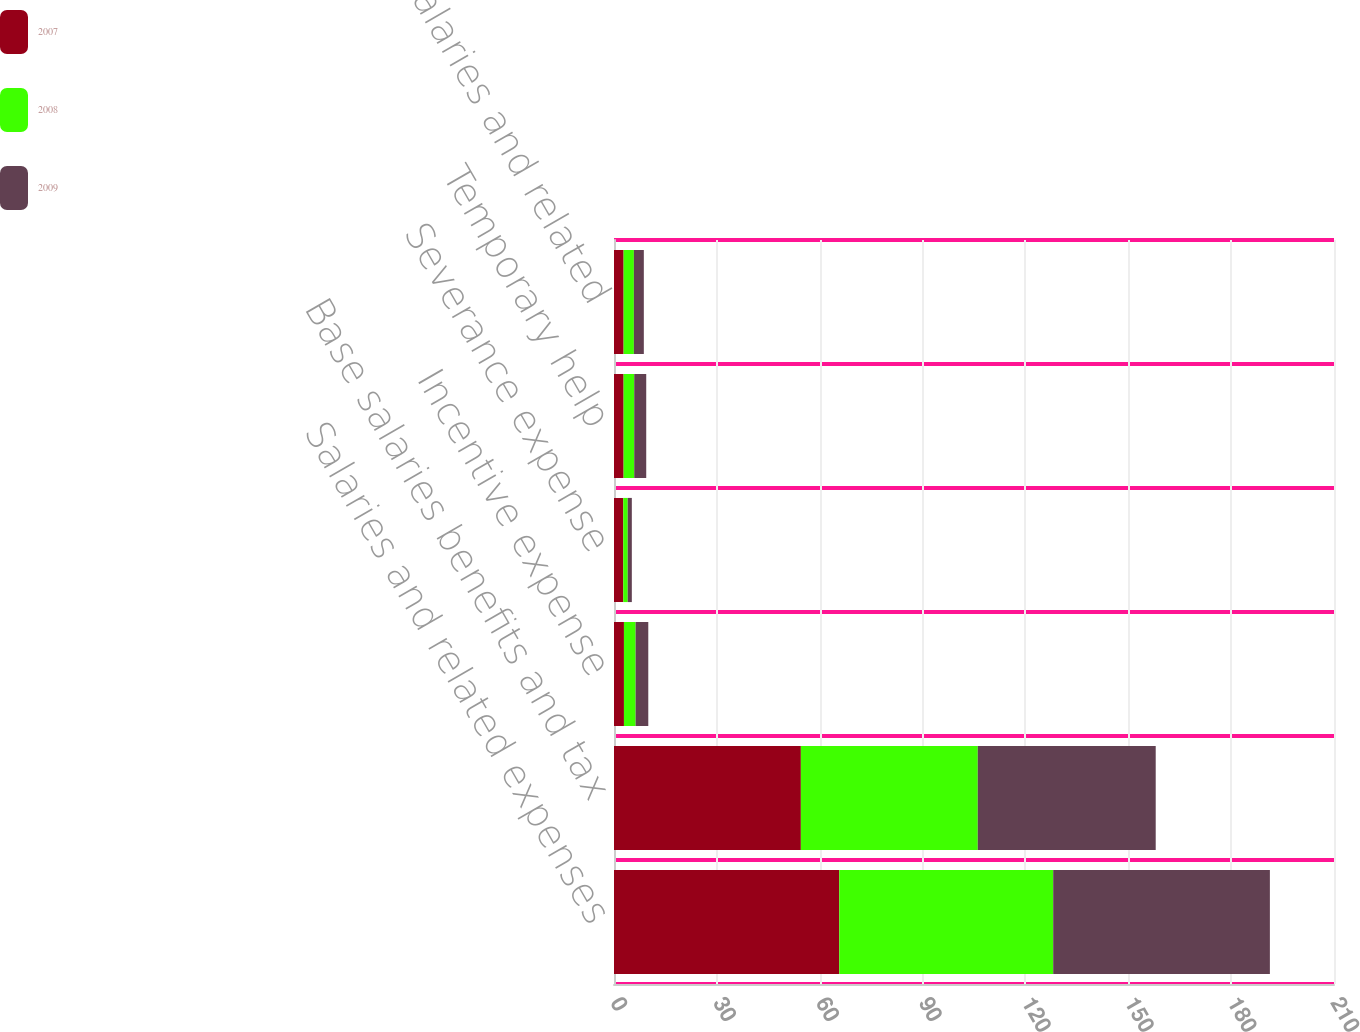<chart> <loc_0><loc_0><loc_500><loc_500><stacked_bar_chart><ecel><fcel>Salaries and related expenses<fcel>Base salaries benefits and tax<fcel>Incentive expense<fcel>Severance expense<fcel>Temporary help<fcel>All other salaries and related<nl><fcel>2007<fcel>65.7<fcel>54.5<fcel>2.9<fcel>2.7<fcel>2.8<fcel>2.8<nl><fcel>2008<fcel>62.4<fcel>51.6<fcel>3.4<fcel>1.3<fcel>3.1<fcel>3<nl><fcel>2009<fcel>63.2<fcel>51.9<fcel>3.7<fcel>1.2<fcel>3.5<fcel>2.9<nl></chart> 